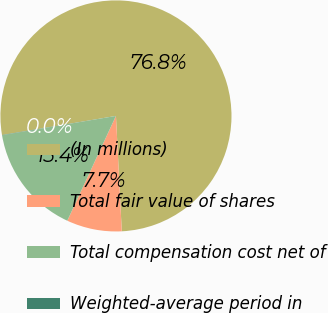<chart> <loc_0><loc_0><loc_500><loc_500><pie_chart><fcel>(In millions)<fcel>Total fair value of shares<fcel>Total compensation cost net of<fcel>Weighted-average period in<nl><fcel>76.84%<fcel>7.72%<fcel>15.4%<fcel>0.04%<nl></chart> 